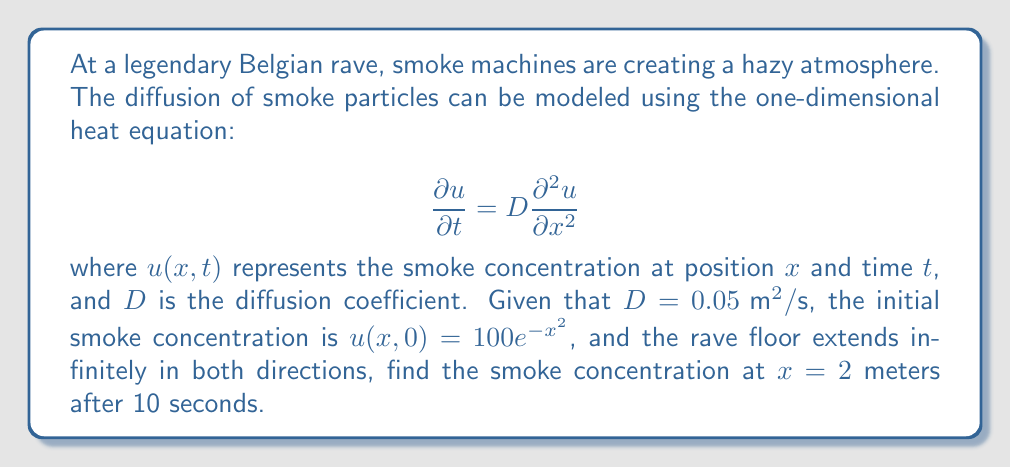Can you answer this question? To solve this problem, we'll use the fundamental solution of the heat equation, also known as the Green's function. For an initial condition $u(x,0) = f(x)$ and an infinite domain, the solution is given by:

$$u(x,t) = \frac{1}{\sqrt{4\pi Dt}} \int_{-\infty}^{\infty} f(y) e^{-\frac{(x-y)^2}{4Dt}} dy$$

Let's break this down step-by-step:

1) We're given $D = 0.05 \text{ m}^2/\text{s}$, $t = 10 \text{ s}$, $x = 2 \text{ m}$, and $f(y) = 100e^{-y^2}$.

2) Substituting these into the solution:

   $$u(2,10) = \frac{1}{\sqrt{4\pi (0.05)(10)}} \int_{-\infty}^{\infty} 100e^{-y^2} e^{-\frac{(2-y)^2}{4(0.05)(10)}} dy$$

3) Simplify the constants:

   $$u(2,10) = \frac{100}{\sqrt{2\pi}} \int_{-\infty}^{\infty} e^{-y^2} e^{-\frac{(2-y)^2}{2}} dy$$

4) Combine the exponents:

   $$u(2,10) = \frac{100}{\sqrt{2\pi}} \int_{-\infty}^{\infty} e^{-(y^2 + \frac{(2-y)^2}{2})} dy$$

5) Expand the squared term in the second exponent:

   $$u(2,10) = \frac{100}{\sqrt{2\pi}} \int_{-\infty}^{\infty} e^{-(y^2 + \frac{4-4y+y^2}{2})} dy$$

6) Simplify:

   $$u(2,10) = \frac{100}{\sqrt{2\pi}} \int_{-\infty}^{\infty} e^{-(1.5y^2 - 2y + 2)} dy$$

7) Complete the square for $y$:

   $$u(2,10) = \frac{100}{\sqrt{2\pi}} e^{-\frac{4}{3}} \int_{-\infty}^{\infty} e^{-1.5(y-\frac{2}{3})^2} dy$$

8) This integral can be evaluated using the standard Gaussian integral formula:

   $$\int_{-\infty}^{\infty} e^{-ax^2} dx = \sqrt{\frac{\pi}{a}}$$

9) Applying this formula with $a = 1.5$:

   $$u(2,10) = \frac{100}{\sqrt{2\pi}} e^{-\frac{4}{3}} \sqrt{\frac{\pi}{1.5}}$$

10) Simplify:

    $$u(2,10) = \frac{100}{\sqrt{3}} e^{-\frac{4}{3}} \approx 15.96$$
Answer: The smoke concentration at $x = 2$ meters after 10 seconds is approximately 15.96 units. 